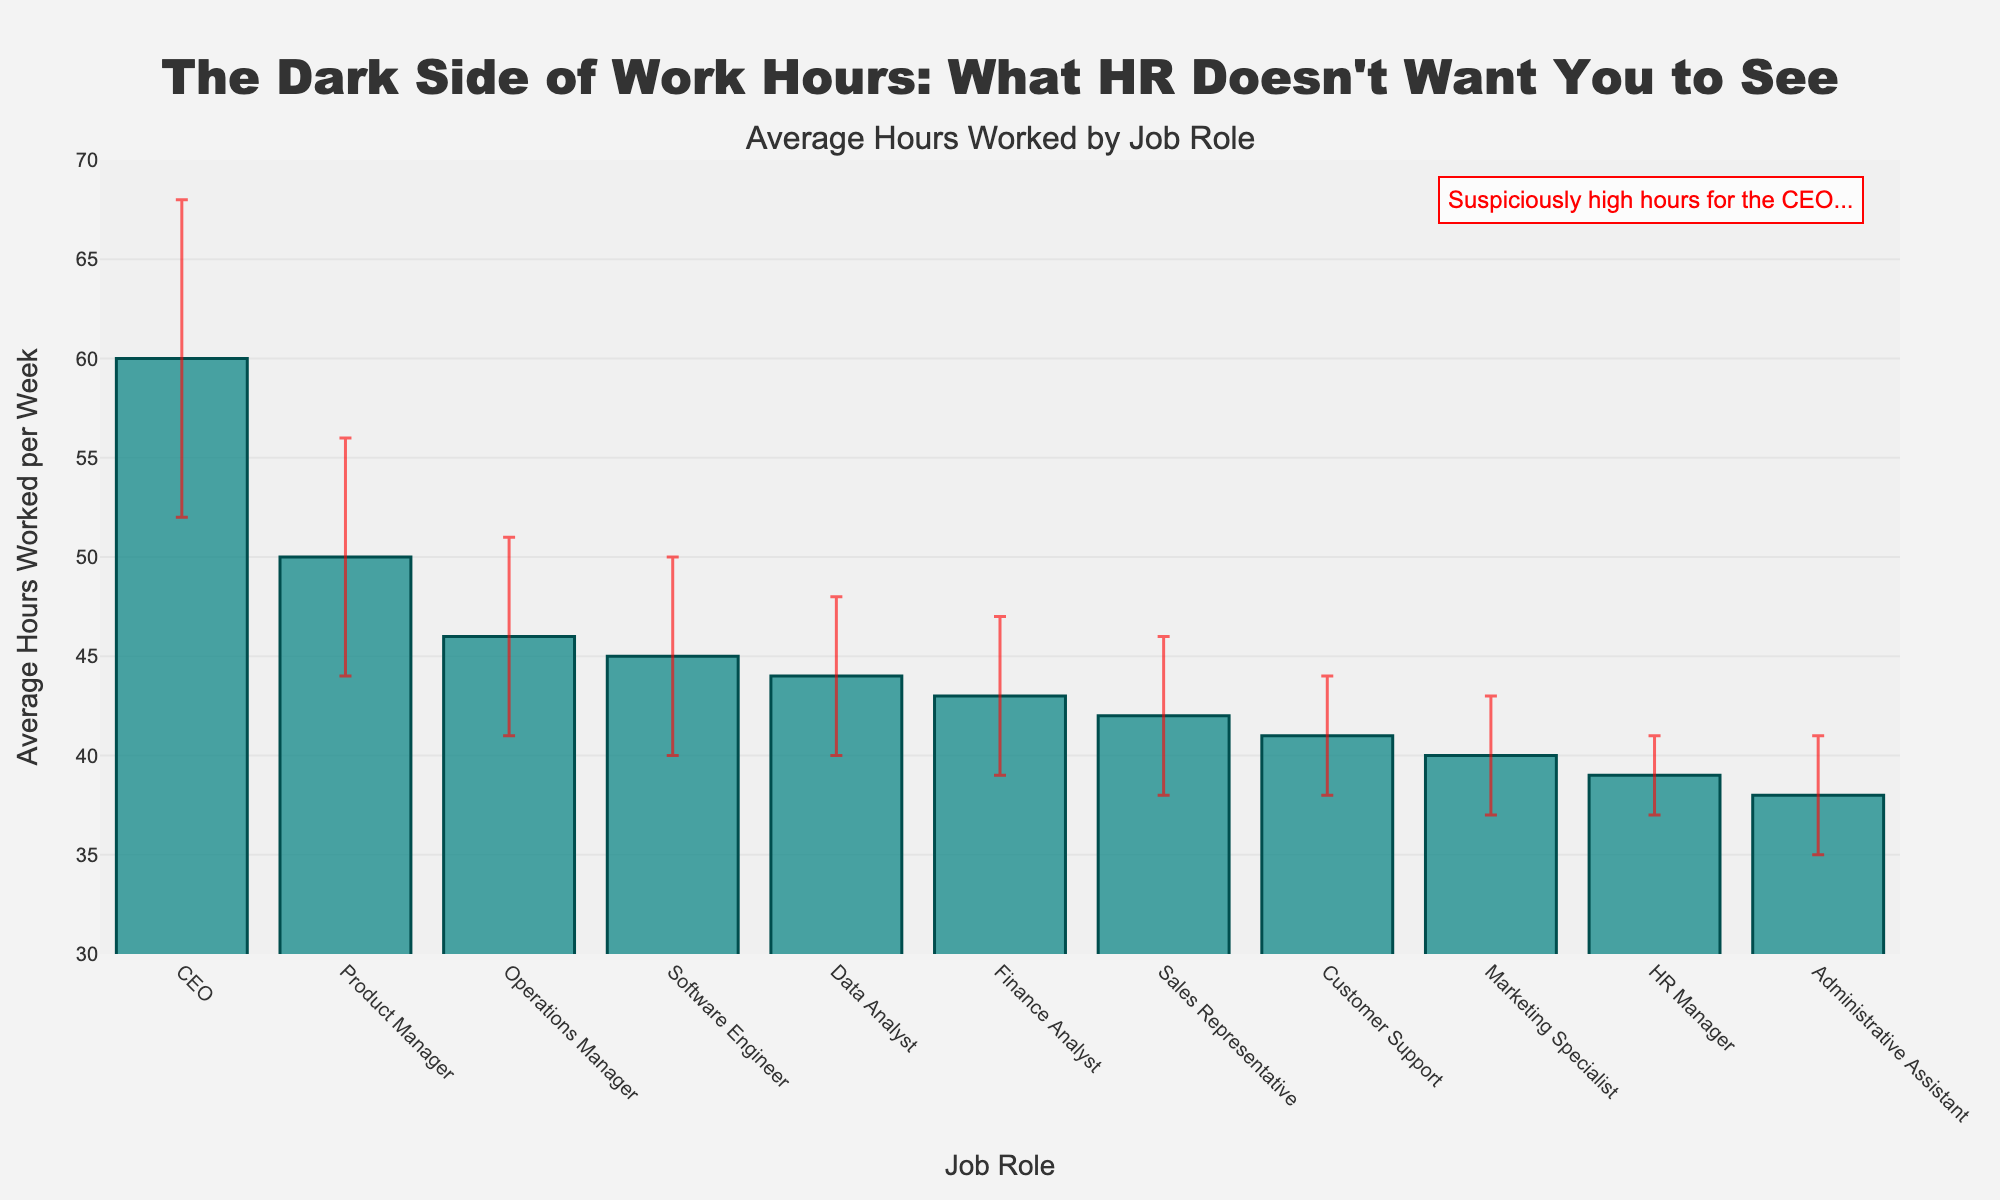Which job role has the highest average hours worked per week? The CEO has the highest average hours worked per week as indicated by the highest bar on the plot.
Answer: CEO Which job role has the lowest average hours worked per week? The Administrative Assistant has the lowest average hours worked per week as indicated by the shortest bar on the plot.
Answer: Administrative Assistant How many job roles have an average of more than 45 hours worked per week? By examining the plot, there are four job roles with bars extending above the 45-hour mark: Product Manager, Operations Manager, Data Analyst, and CEO.
Answer: 4 Which job roles have standard deviations equal to or greater than 5 hours? Observing the error bars in the plot, the job roles with standard deviations equal to or greater than 5 hours are Software Engineer, Product Manager, Operations Manager, and CEO.
Answer: Software Engineer, Product Manager, Operations Manager, CEO What is the average hours worked per week by Sales Representatives compared to Finance Analysts? By comparing the height of the bars for Sales Representatives and Finance Analysts, Sales Representatives have an average of 42 hours, whereas Finance Analysts have an average of 43 hours. So, Finance Analysts work 1 hour more on average.
Answer: Finance Analysts work 1 hour more Which job role has the second highest variability in hours worked? The figure shows the CEO with the highest variability, followed by the Product Manager with the second highest variability indicated by the second largest error bar.
Answer: Product Manager Is the average hours worked by an HR Manager greater or less than Operations Manager? From the plot, the average hours worked by an HR Manager is 39, which is less than that of an Operations Manager which is 46.
Answer: Less How does the average hours worked by the Customer Support team compare to that of Software Engineers? The plot indicates that Customer Support works 41 hours on average, while Software Engineers work 45 hours. Therefore, Software Engineers work 4 hours more on average than Customer Support.
Answer: Software Engineers work 4 hours more What can be inferred about work hours for Product Manager and Data Analyst in terms of similarity? Both Product Manager and Data Analyst have high average hours worked per week, but Product Manager averages 50 hours while Data Analyst averages 44 hours. Both have a relatively high variability indicated by their error bars.
Answer: Product Manager works more hours with high variability compared to Data Analyst What observation can you make about the average hours worked per week by the Marketing Specialist? Observing the plot, Marketing Specialists work 40 hours per week on average, which is relatively low compared to other roles and they have a low variability indicated by their error bar.
Answer: 40 hours per week with low variability 